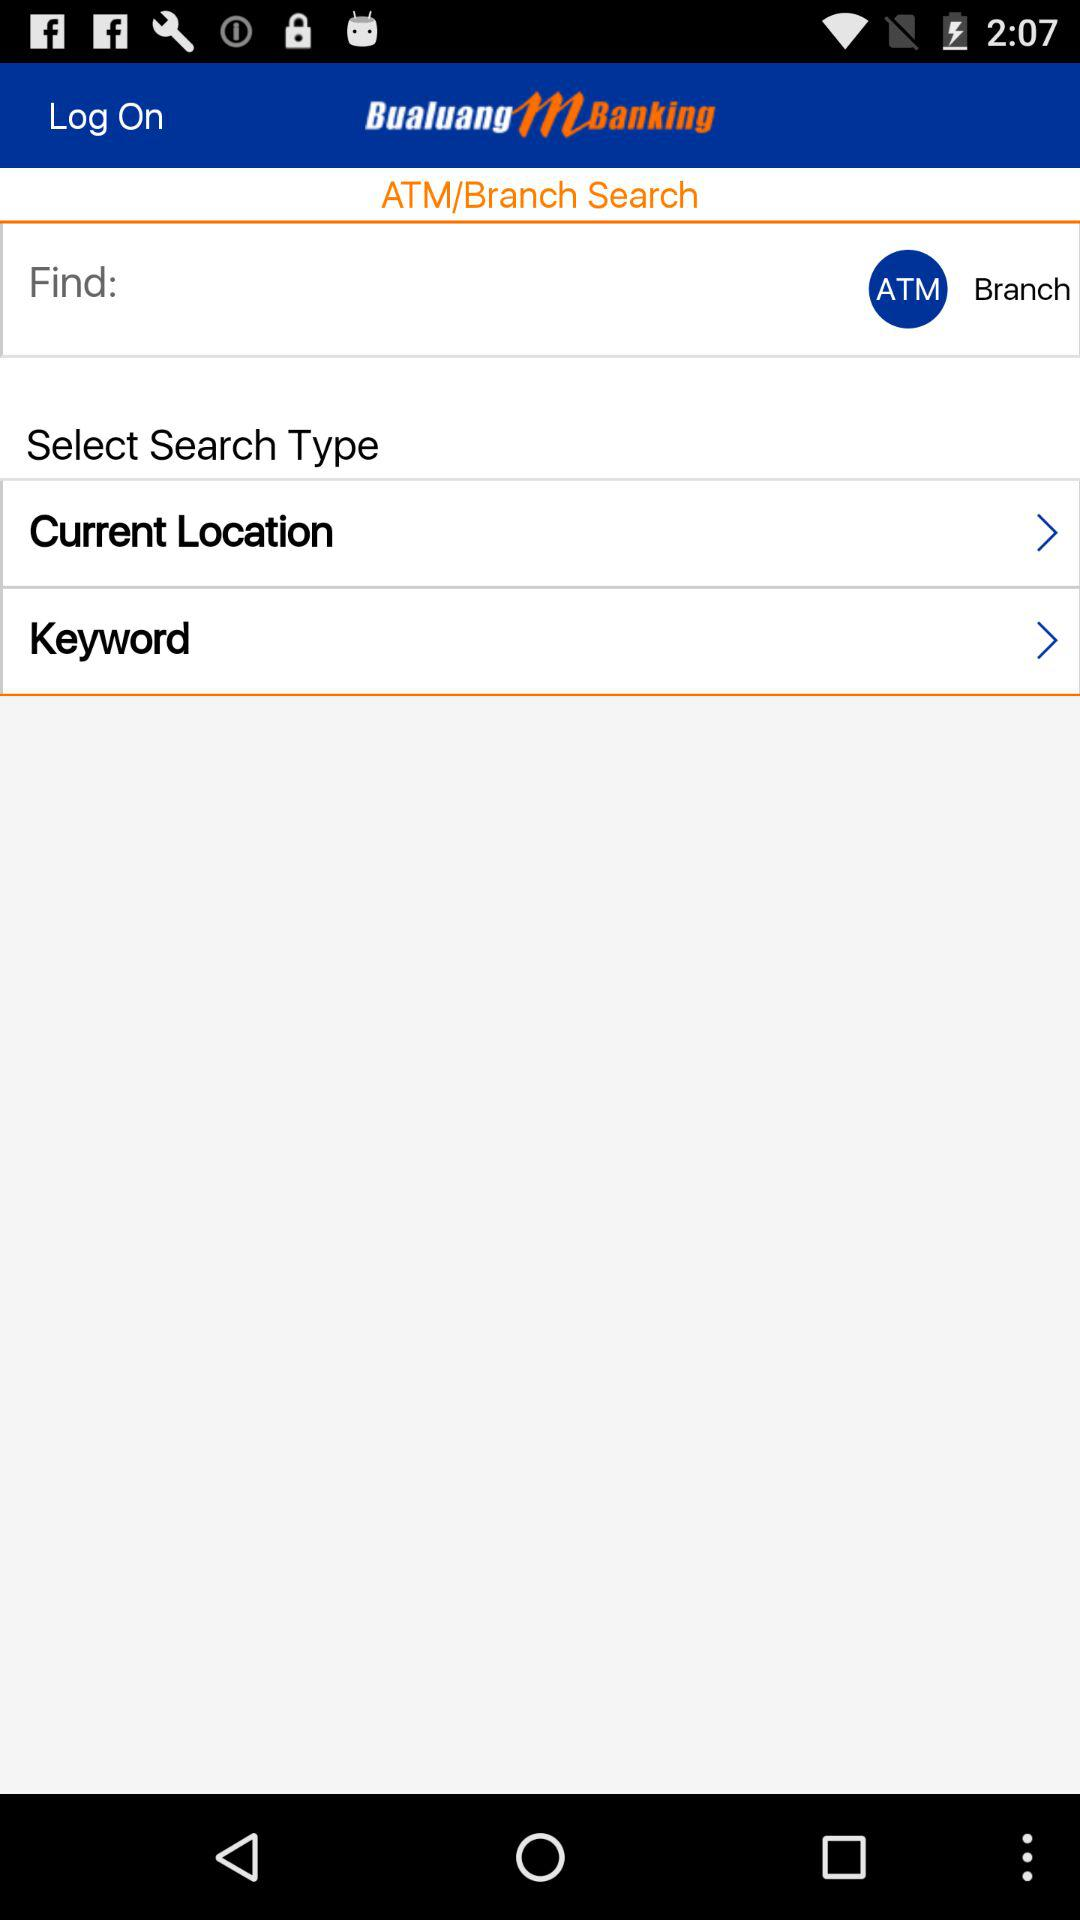Where is the nearest ATM?
When the provided information is insufficient, respond with <no answer>. <no answer> 